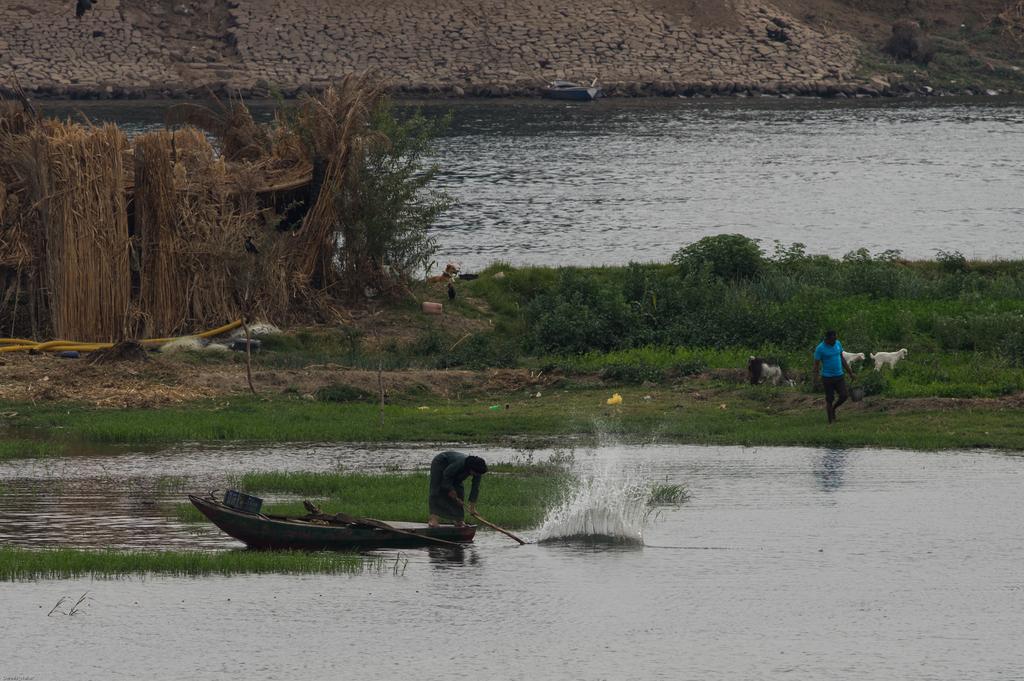Could you give a brief overview of what you see in this image? In this image we can see two persons. Also there is a boat on the water. And there is grass and plants. In the back we can see grass straws. Also there are animals. In the background we can see water. And there is a stone wall. And there is a boat on the water. 